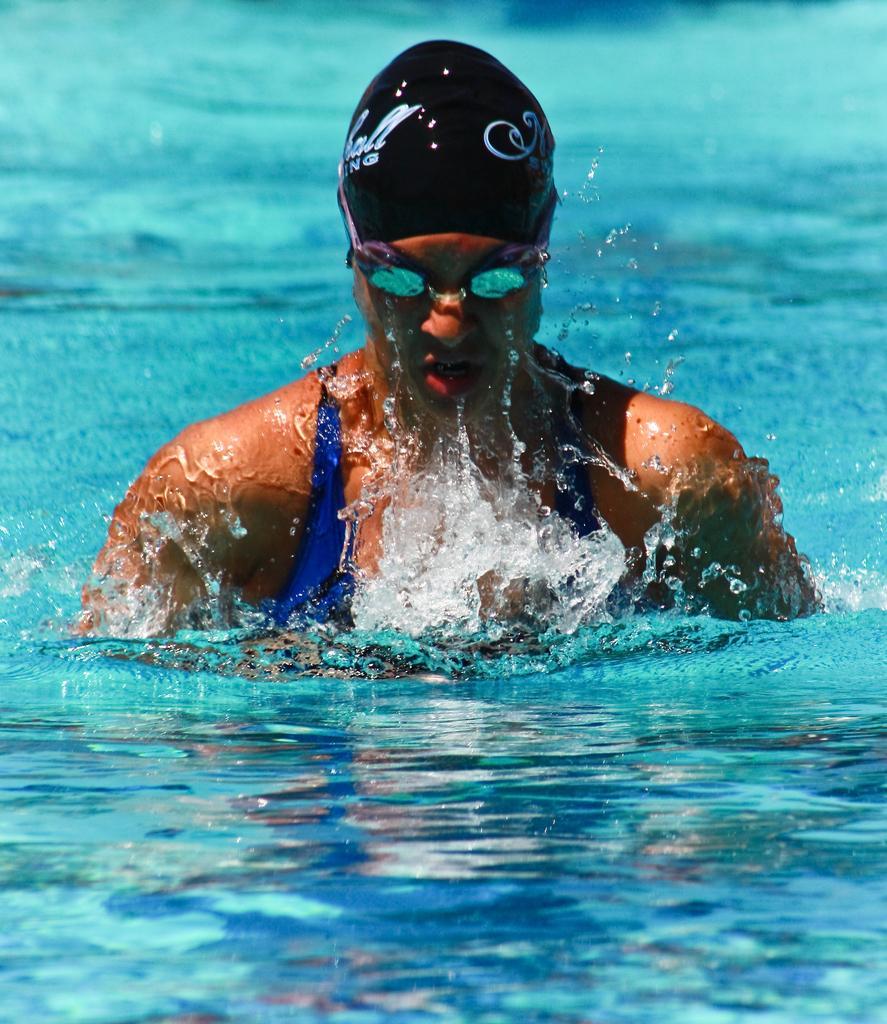Could you give a brief overview of what you see in this image? In this image I can see a person in the water. The person is wearing a cap, glasses and a swimsuit. 